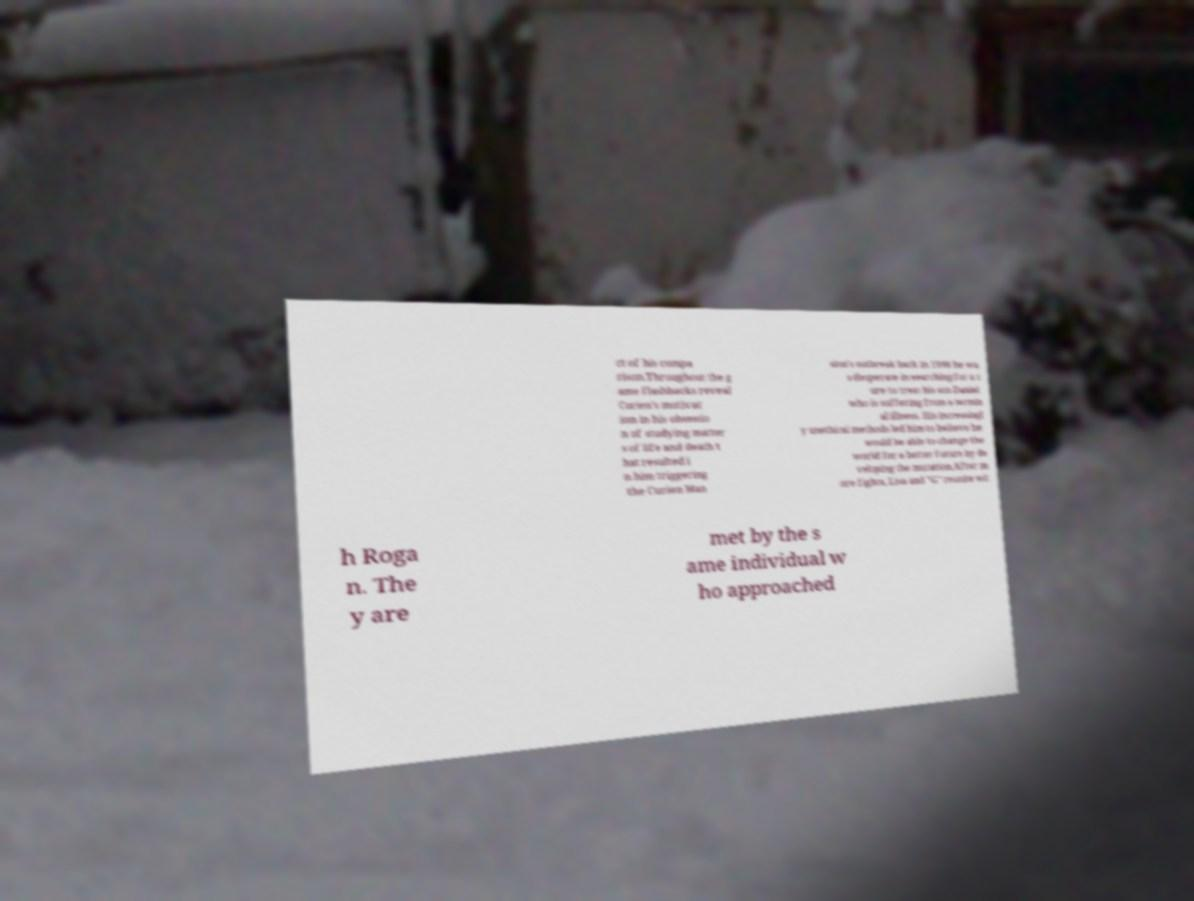There's text embedded in this image that I need extracted. Can you transcribe it verbatim? ct of his compa rison.Throughout the g ame flashbacks reveal Curien's motivat ion in his obsessio n of studying matter s of life and death t hat resulted i n him triggering the Curien Man sion's outbreak back in 1998 he wa s desperate in searching for a c ure to treat his son Daniel who is suffering from a termin al illness. His increasingl y unethical methods led him to believe he would be able to change the world for a better future by de veloping the mutation.After m ore fights, Lisa and "G" reunite wit h Roga n. The y are met by the s ame individual w ho approached 